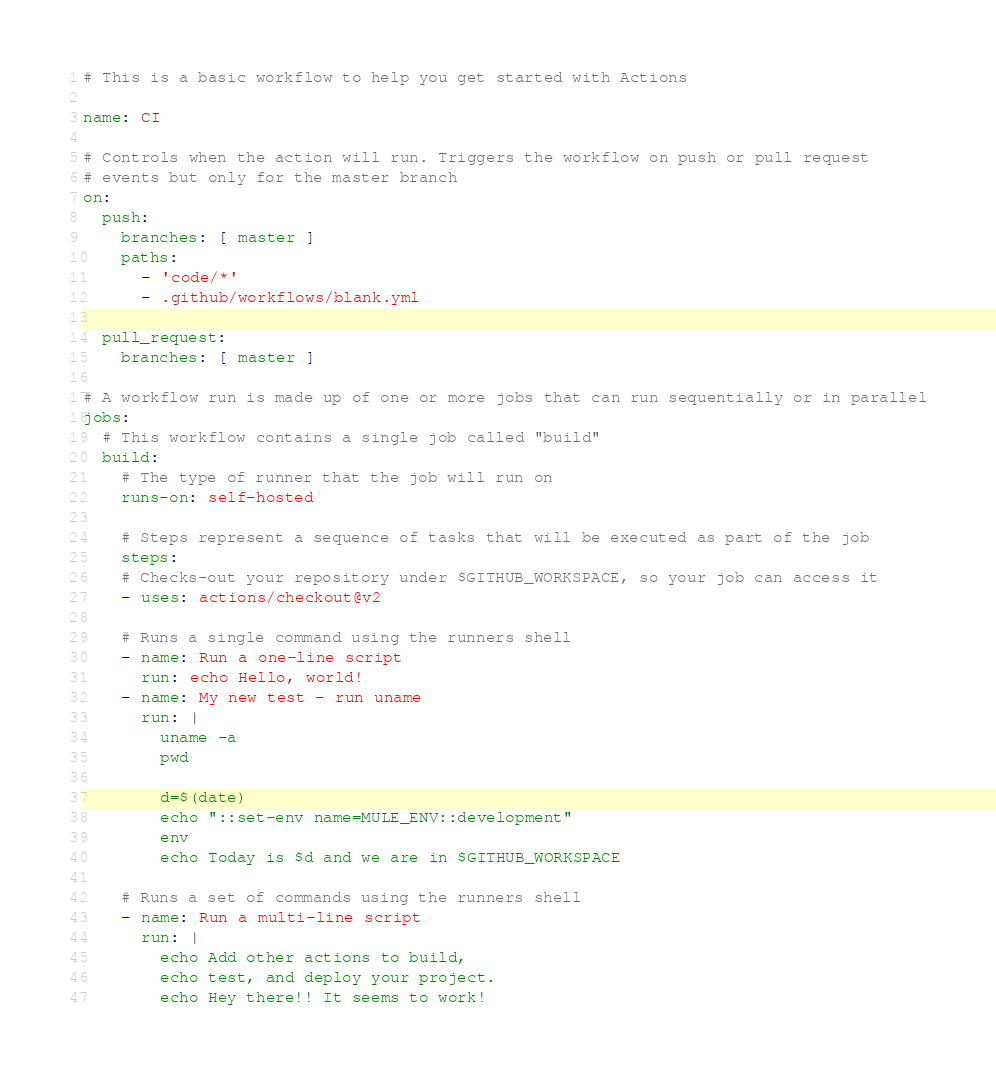Convert code to text. <code><loc_0><loc_0><loc_500><loc_500><_YAML_># This is a basic workflow to help you get started with Actions

name: CI

# Controls when the action will run. Triggers the workflow on push or pull request
# events but only for the master branch
on:
  push:
    branches: [ master ]
    paths: 
      - 'code/*'
      - .github/workflows/blank.yml
          
  pull_request:
    branches: [ master ]

# A workflow run is made up of one or more jobs that can run sequentially or in parallel
jobs:
  # This workflow contains a single job called "build"
  build:
    # The type of runner that the job will run on
    runs-on: self-hosted

    # Steps represent a sequence of tasks that will be executed as part of the job
    steps:
    # Checks-out your repository under $GITHUB_WORKSPACE, so your job can access it
    - uses: actions/checkout@v2

    # Runs a single command using the runners shell
    - name: Run a one-line script
      run: echo Hello, world!
    - name: My new test - run uname
      run: |
        uname -a
        pwd
        
        d=$(date)
        echo "::set-env name=MULE_ENV::development"
        env
        echo Today is $d and we are in $GITHUB_WORKSPACE
    
    # Runs a set of commands using the runners shell
    - name: Run a multi-line script
      run: |
        echo Add other actions to build,
        echo test, and deploy your project.
        echo Hey there!! It seems to work!
</code> 